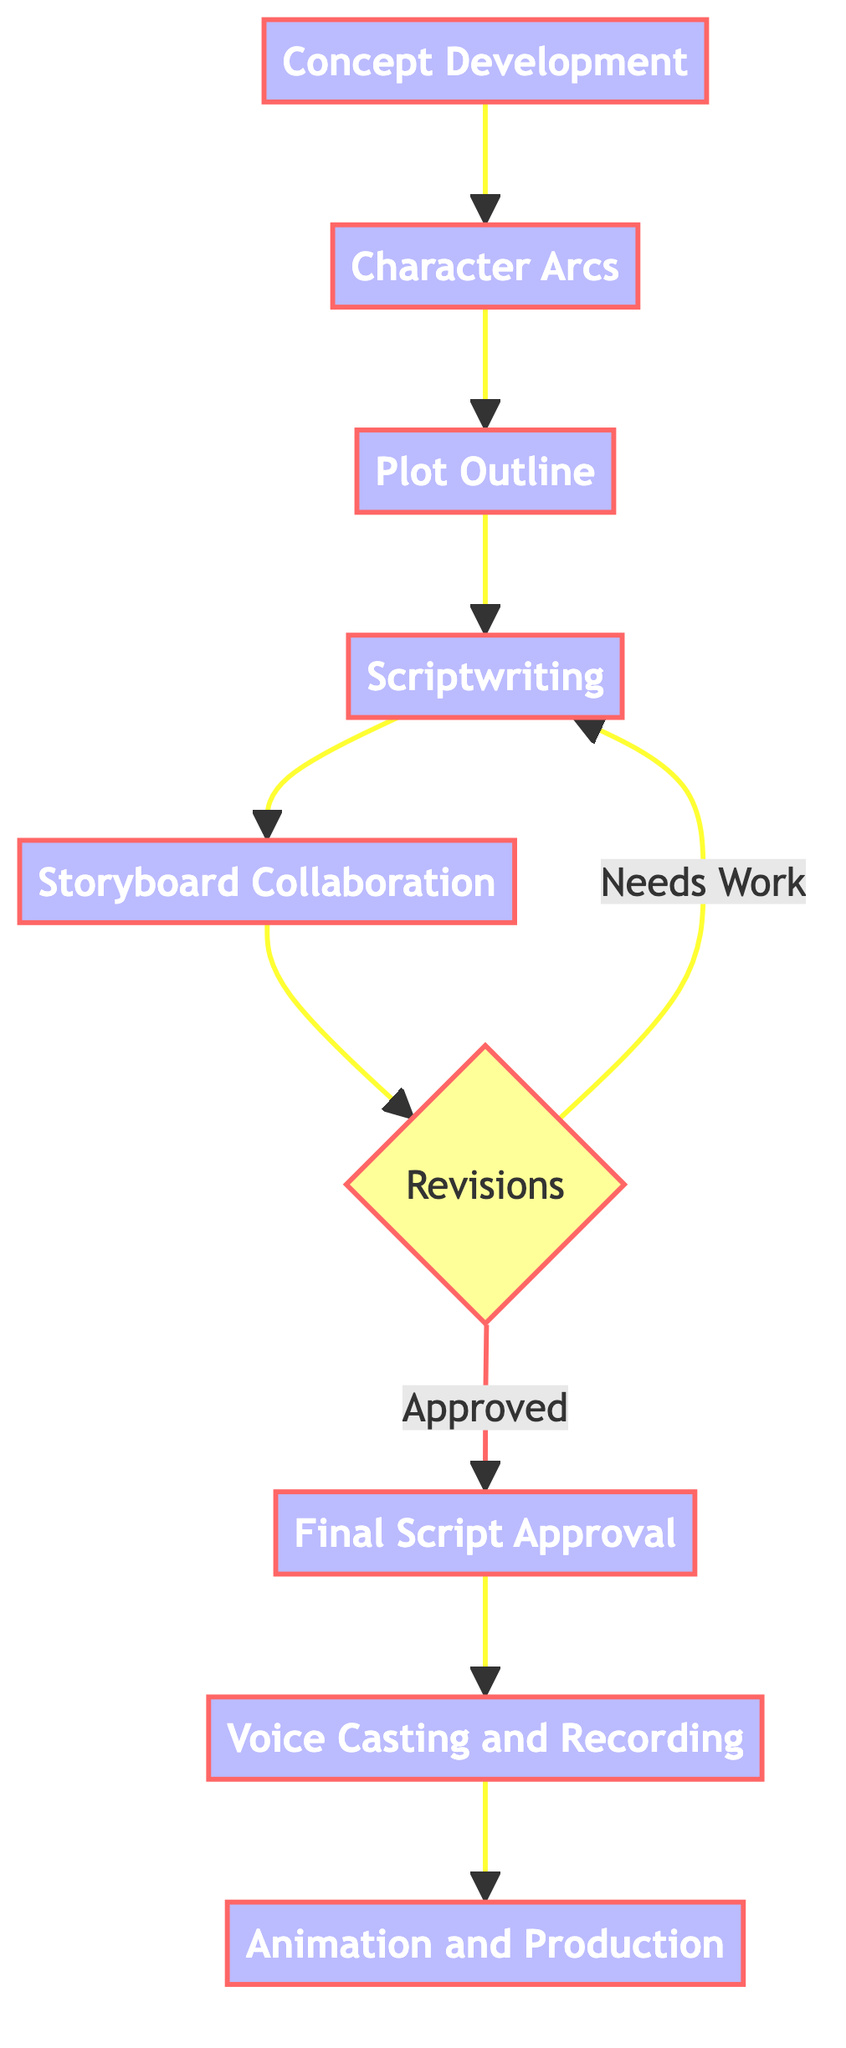What is the first step in the storyline development process? The first step in the process is represented by the node "Concept Development", which initiates the entire flow.
Answer: Concept Development How many main processes are involved in the storyline development? By counting the nodes in the diagram, there are a total of eight main processes from "Concept Development" to "Animation and Production."
Answer: Eight What is the relationship between "Revisions" and "Final Script Approval"? "Revisions" is a decision point, and if the script is approved, the flow moves to "Final Script Approval"; otherwise, it loops back to "Scriptwriting".
Answer: Decision point What activities are involved in "Scriptwriting"? The activities for "Scriptwriting" include "Dialogue Writing" and "Scene Descriptions".
Answer: Dialogue Writing, Scene Descriptions Who are the participants in the "Storyboarding Collaboration" node? The participants in this node are the "Screenwriter" and "Storyboard Artist," who work together during this phase.
Answer: Screenwriter, Storyboard Artist What happens if the revisions are approved? If the revisions are approved, the process moves forward to "Final Script Approval," indicating that the script has passed the review stage.
Answer: Final Script Approval At which step is the voice casting and recording conducted? The voice casting and recording occurs after the "Final Script Approval," as it relies on the finalized content of the script.
Answer: Voice Casting and Recording Which participants are involved in the "Animation and Production" phase? In this phase, the participants are "Animators" and "Editors," who are responsible for creating the final visual output of the episode.
Answer: Animators, Editors What is indicated by the node labeled "Revisions"? The node "Revisions" indicates a decision point where the script and storyline may either be approved or require further work.
Answer: Decision point 